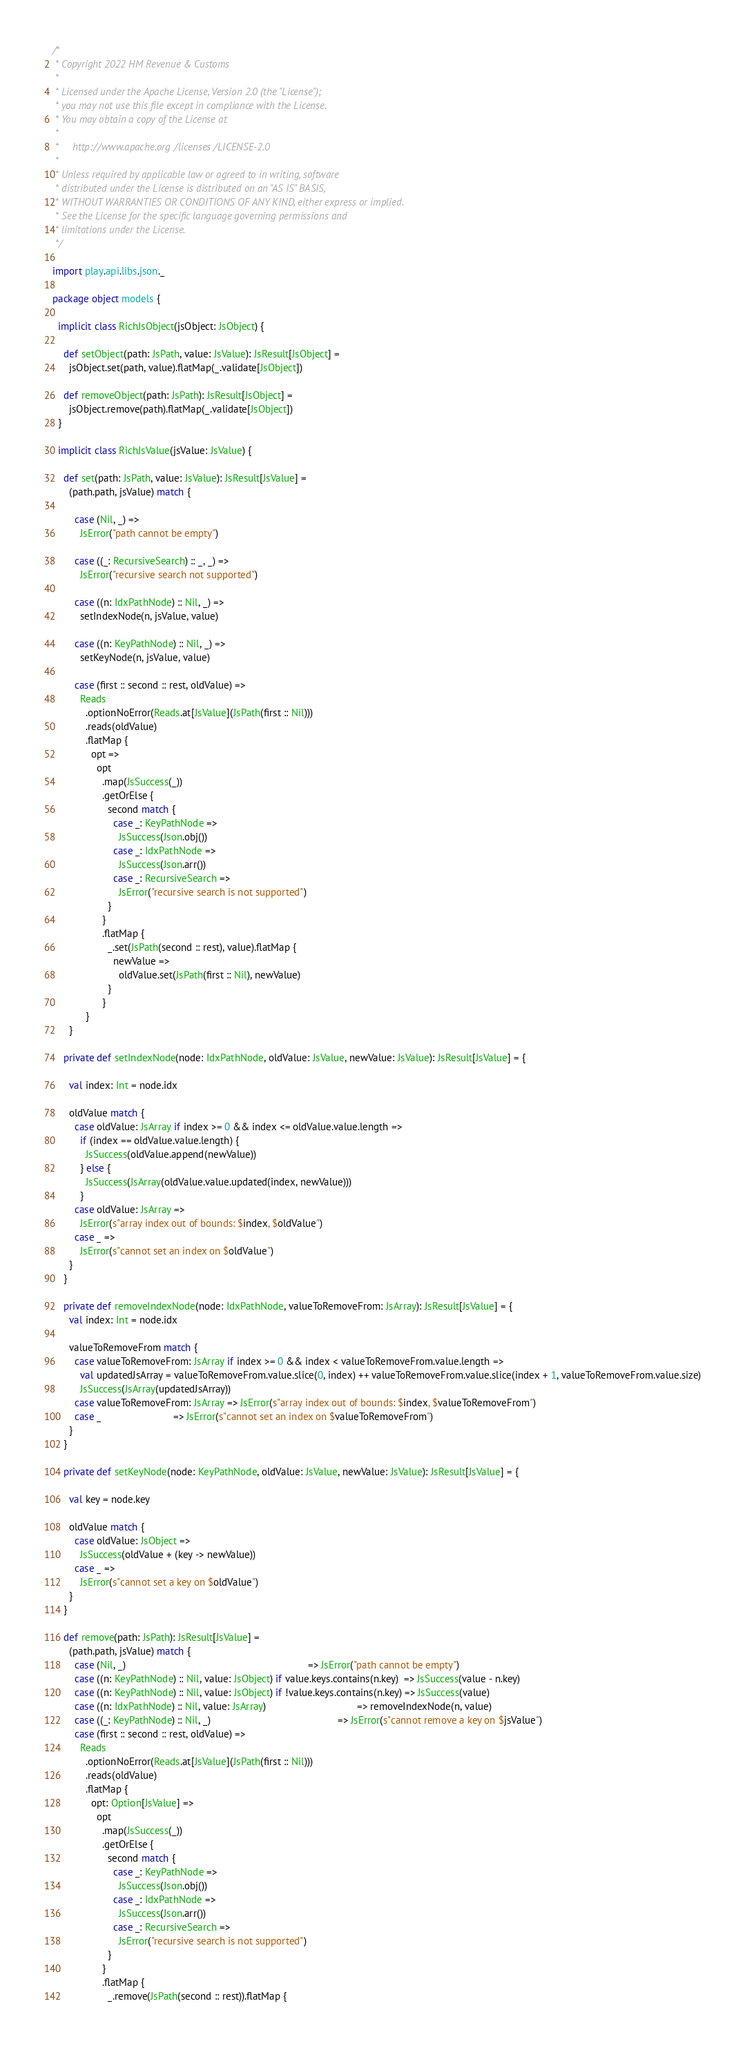<code> <loc_0><loc_0><loc_500><loc_500><_Scala_>/*
 * Copyright 2022 HM Revenue & Customs
 *
 * Licensed under the Apache License, Version 2.0 (the "License");
 * you may not use this file except in compliance with the License.
 * You may obtain a copy of the License at
 *
 *     http://www.apache.org/licenses/LICENSE-2.0
 *
 * Unless required by applicable law or agreed to in writing, software
 * distributed under the License is distributed on an "AS IS" BASIS,
 * WITHOUT WARRANTIES OR CONDITIONS OF ANY KIND, either express or implied.
 * See the License for the specific language governing permissions and
 * limitations under the License.
 */

import play.api.libs.json._

package object models {

  implicit class RichJsObject(jsObject: JsObject) {

    def setObject(path: JsPath, value: JsValue): JsResult[JsObject] =
      jsObject.set(path, value).flatMap(_.validate[JsObject])

    def removeObject(path: JsPath): JsResult[JsObject] =
      jsObject.remove(path).flatMap(_.validate[JsObject])
  }

  implicit class RichJsValue(jsValue: JsValue) {

    def set(path: JsPath, value: JsValue): JsResult[JsValue] =
      (path.path, jsValue) match {

        case (Nil, _) =>
          JsError("path cannot be empty")

        case ((_: RecursiveSearch) :: _, _) =>
          JsError("recursive search not supported")

        case ((n: IdxPathNode) :: Nil, _) =>
          setIndexNode(n, jsValue, value)

        case ((n: KeyPathNode) :: Nil, _) =>
          setKeyNode(n, jsValue, value)

        case (first :: second :: rest, oldValue) =>
          Reads
            .optionNoError(Reads.at[JsValue](JsPath(first :: Nil)))
            .reads(oldValue)
            .flatMap {
              opt =>
                opt
                  .map(JsSuccess(_))
                  .getOrElse {
                    second match {
                      case _: KeyPathNode =>
                        JsSuccess(Json.obj())
                      case _: IdxPathNode =>
                        JsSuccess(Json.arr())
                      case _: RecursiveSearch =>
                        JsError("recursive search is not supported")
                    }
                  }
                  .flatMap {
                    _.set(JsPath(second :: rest), value).flatMap {
                      newValue =>
                        oldValue.set(JsPath(first :: Nil), newValue)
                    }
                  }
            }
      }

    private def setIndexNode(node: IdxPathNode, oldValue: JsValue, newValue: JsValue): JsResult[JsValue] = {

      val index: Int = node.idx

      oldValue match {
        case oldValue: JsArray if index >= 0 && index <= oldValue.value.length =>
          if (index == oldValue.value.length) {
            JsSuccess(oldValue.append(newValue))
          } else {
            JsSuccess(JsArray(oldValue.value.updated(index, newValue)))
          }
        case oldValue: JsArray =>
          JsError(s"array index out of bounds: $index, $oldValue")
        case _ =>
          JsError(s"cannot set an index on $oldValue")
      }
    }

    private def removeIndexNode(node: IdxPathNode, valueToRemoveFrom: JsArray): JsResult[JsValue] = {
      val index: Int = node.idx

      valueToRemoveFrom match {
        case valueToRemoveFrom: JsArray if index >= 0 && index < valueToRemoveFrom.value.length =>
          val updatedJsArray = valueToRemoveFrom.value.slice(0, index) ++ valueToRemoveFrom.value.slice(index + 1, valueToRemoveFrom.value.size)
          JsSuccess(JsArray(updatedJsArray))
        case valueToRemoveFrom: JsArray => JsError(s"array index out of bounds: $index, $valueToRemoveFrom")
        case _                          => JsError(s"cannot set an index on $valueToRemoveFrom")
      }
    }

    private def setKeyNode(node: KeyPathNode, oldValue: JsValue, newValue: JsValue): JsResult[JsValue] = {

      val key = node.key

      oldValue match {
        case oldValue: JsObject =>
          JsSuccess(oldValue + (key -> newValue))
        case _ =>
          JsError(s"cannot set a key on $oldValue")
      }
    }

    def remove(path: JsPath): JsResult[JsValue] =
      (path.path, jsValue) match {
        case (Nil, _)                                                                  => JsError("path cannot be empty")
        case ((n: KeyPathNode) :: Nil, value: JsObject) if value.keys.contains(n.key)  => JsSuccess(value - n.key)
        case ((n: KeyPathNode) :: Nil, value: JsObject) if !value.keys.contains(n.key) => JsSuccess(value)
        case ((n: IdxPathNode) :: Nil, value: JsArray)                                 => removeIndexNode(n, value)
        case ((_: KeyPathNode) :: Nil, _)                                              => JsError(s"cannot remove a key on $jsValue")
        case (first :: second :: rest, oldValue) =>
          Reads
            .optionNoError(Reads.at[JsValue](JsPath(first :: Nil)))
            .reads(oldValue)
            .flatMap {
              opt: Option[JsValue] =>
                opt
                  .map(JsSuccess(_))
                  .getOrElse {
                    second match {
                      case _: KeyPathNode =>
                        JsSuccess(Json.obj())
                      case _: IdxPathNode =>
                        JsSuccess(Json.arr())
                      case _: RecursiveSearch =>
                        JsError("recursive search is not supported")
                    }
                  }
                  .flatMap {
                    _.remove(JsPath(second :: rest)).flatMap {</code> 